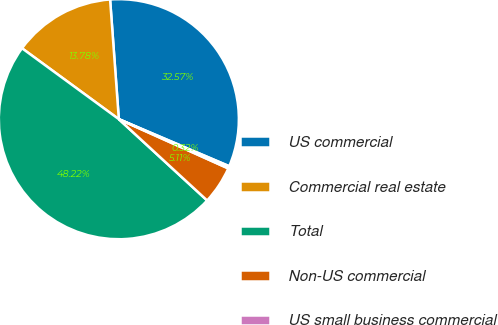Convert chart to OTSL. <chart><loc_0><loc_0><loc_500><loc_500><pie_chart><fcel>US commercial<fcel>Commercial real estate<fcel>Total<fcel>Non-US commercial<fcel>US small business commercial<nl><fcel>32.57%<fcel>13.78%<fcel>48.22%<fcel>5.11%<fcel>0.32%<nl></chart> 